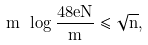<formula> <loc_0><loc_0><loc_500><loc_500>m \ \log \frac { 4 8 e N } { m } \leq \sqrt { n } ,</formula> 